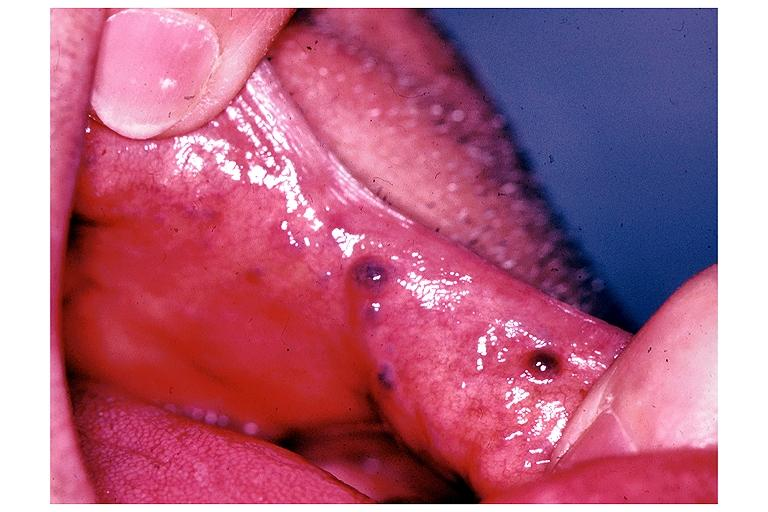does this image show varix?
Answer the question using a single word or phrase. Yes 